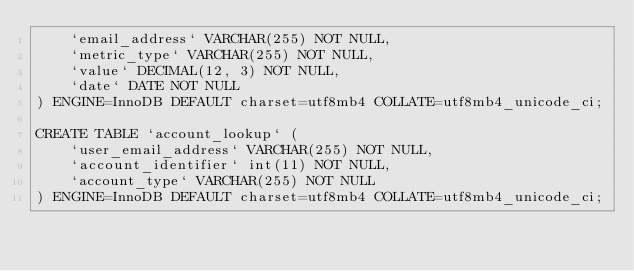<code> <loc_0><loc_0><loc_500><loc_500><_SQL_>    `email_address` VARCHAR(255) NOT NULL,
    `metric_type` VARCHAR(255) NOT NULL,
    `value` DECIMAL(12, 3) NOT NULL,
    `date` DATE NOT NULL
) ENGINE=InnoDB DEFAULT charset=utf8mb4 COLLATE=utf8mb4_unicode_ci;

CREATE TABLE `account_lookup` (
    `user_email_address` VARCHAR(255) NOT NULL,
    `account_identifier` int(11) NOT NULL,
    `account_type` VARCHAR(255) NOT NULL
) ENGINE=InnoDB DEFAULT charset=utf8mb4 COLLATE=utf8mb4_unicode_ci;</code> 